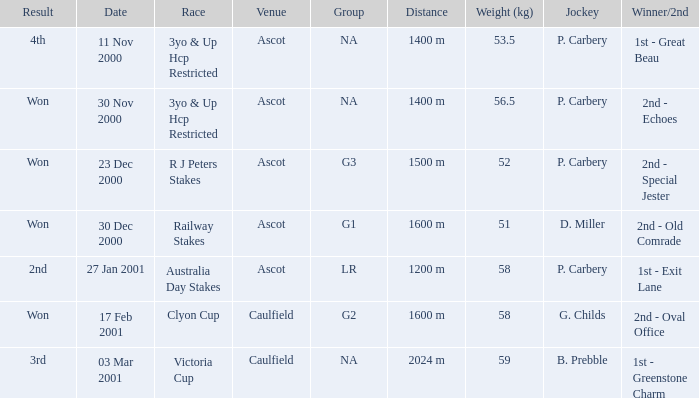What was the result for the railway stakes race? Won. 